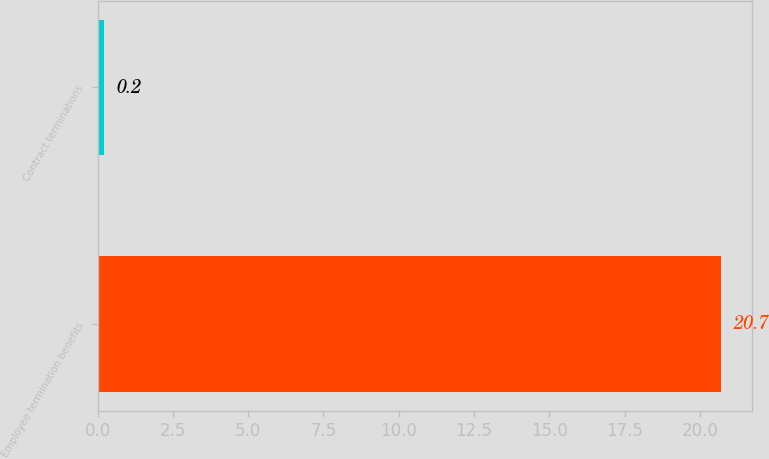Convert chart to OTSL. <chart><loc_0><loc_0><loc_500><loc_500><bar_chart><fcel>Employee termination benefits<fcel>Contract terminations<nl><fcel>20.7<fcel>0.2<nl></chart> 